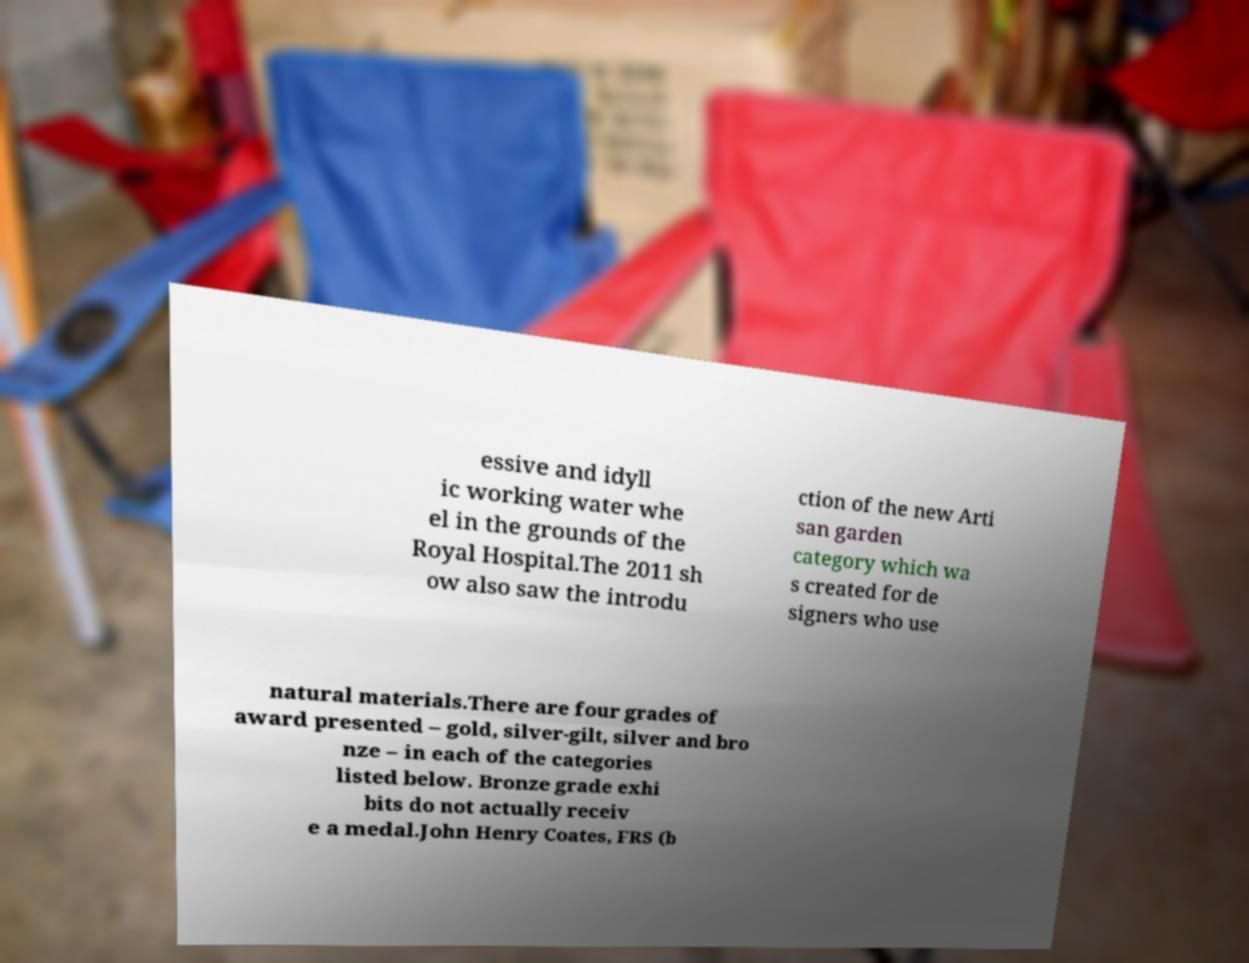Can you accurately transcribe the text from the provided image for me? essive and idyll ic working water whe el in the grounds of the Royal Hospital.The 2011 sh ow also saw the introdu ction of the new Arti san garden category which wa s created for de signers who use natural materials.There are four grades of award presented – gold, silver-gilt, silver and bro nze – in each of the categories listed below. Bronze grade exhi bits do not actually receiv e a medal.John Henry Coates, FRS (b 